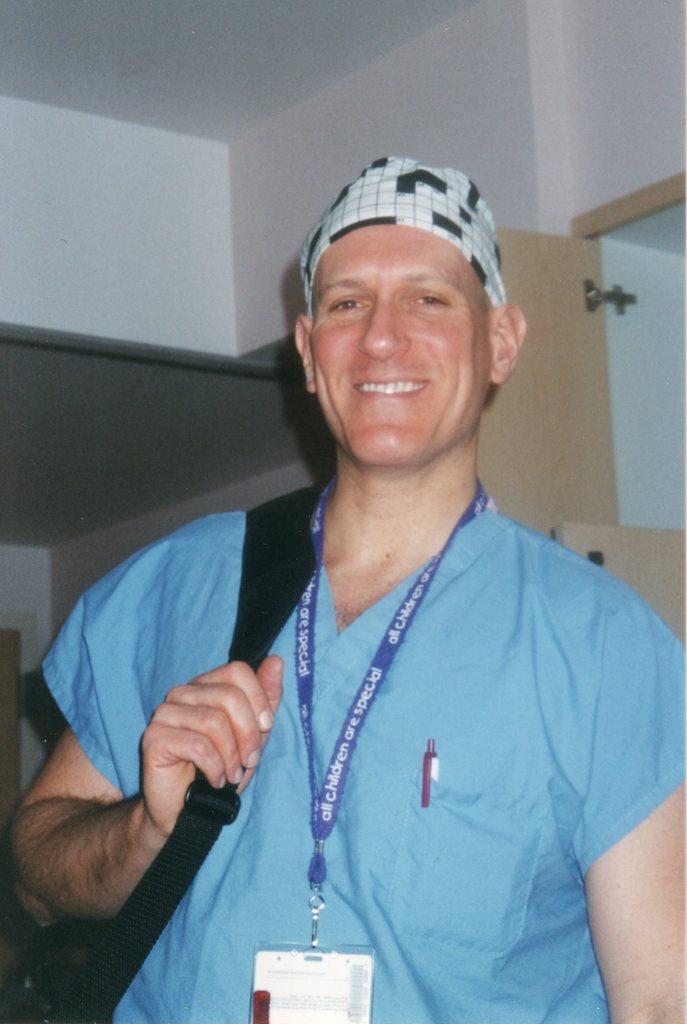Could you give a brief overview of what you see in this image? In the picture I can see a person is holding a bag and smiling. In the background of the image there are walls and door. 